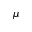Convert formula to latex. <formula><loc_0><loc_0><loc_500><loc_500>\mu</formula> 